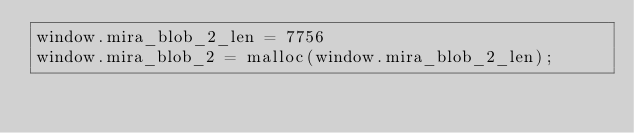Convert code to text. <code><loc_0><loc_0><loc_500><loc_500><_JavaScript_>window.mira_blob_2_len = 7756
window.mira_blob_2 = malloc(window.mira_blob_2_len);</code> 